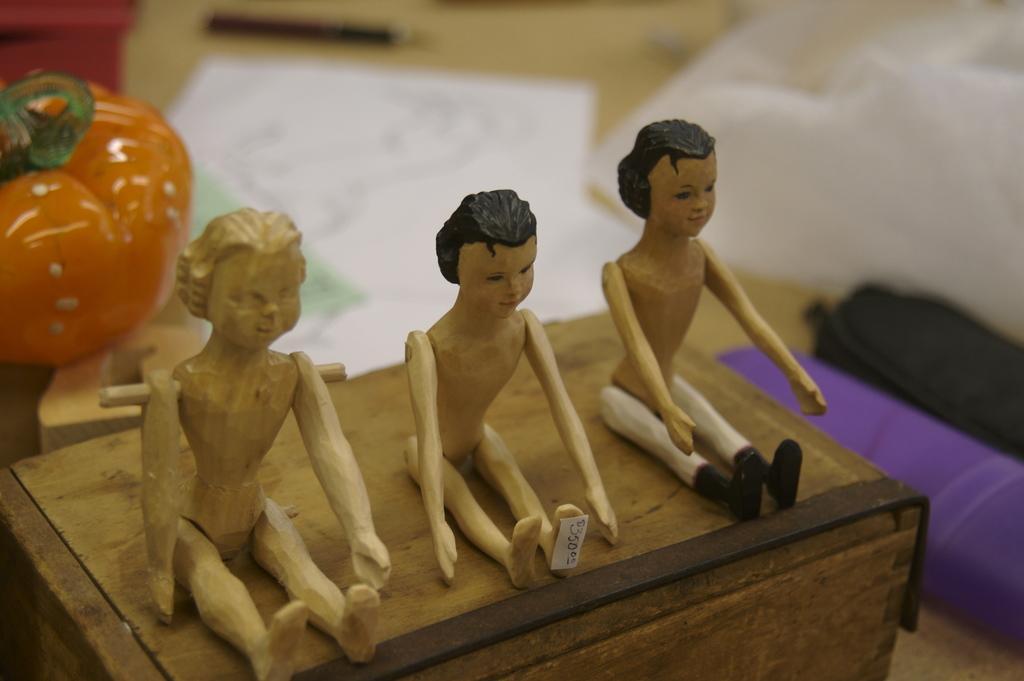Describe this image in one or two sentences. In this picture we can see few figurines, and we can see blurry background. 